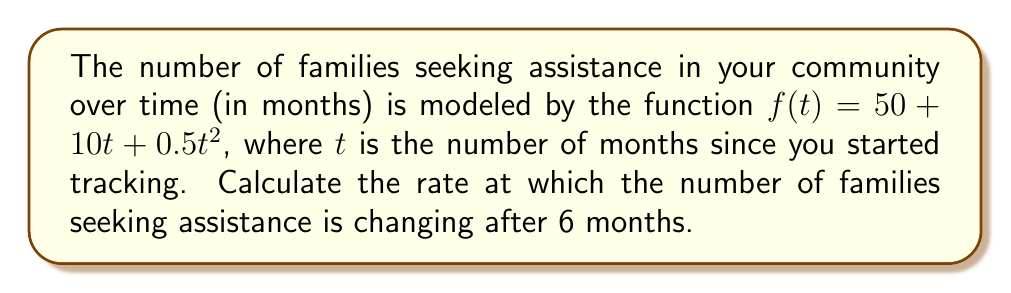Can you solve this math problem? To find the rate at which the number of families seeking assistance is changing after 6 months, we need to calculate the derivative of the function $f(t)$ and evaluate it at $t=6$. Here's the step-by-step process:

1) The given function is $f(t) = 50 + 10t + 0.5t^2$

2) To find the derivative, we apply the power rule and constant rule:
   $$f'(t) = 0 + 10 + 0.5 \cdot 2t = 10 + t$$

3) This derivative $f'(t)$ represents the instantaneous rate of change in the number of families seeking assistance at any given time $t$.

4) To find the rate of change at 6 months, we substitute $t=6$ into $f'(t)$:
   $$f'(6) = 10 + 6 = 16$$

Therefore, after 6 months, the number of families seeking assistance is increasing at a rate of 16 families per month.
Answer: 16 families/month 